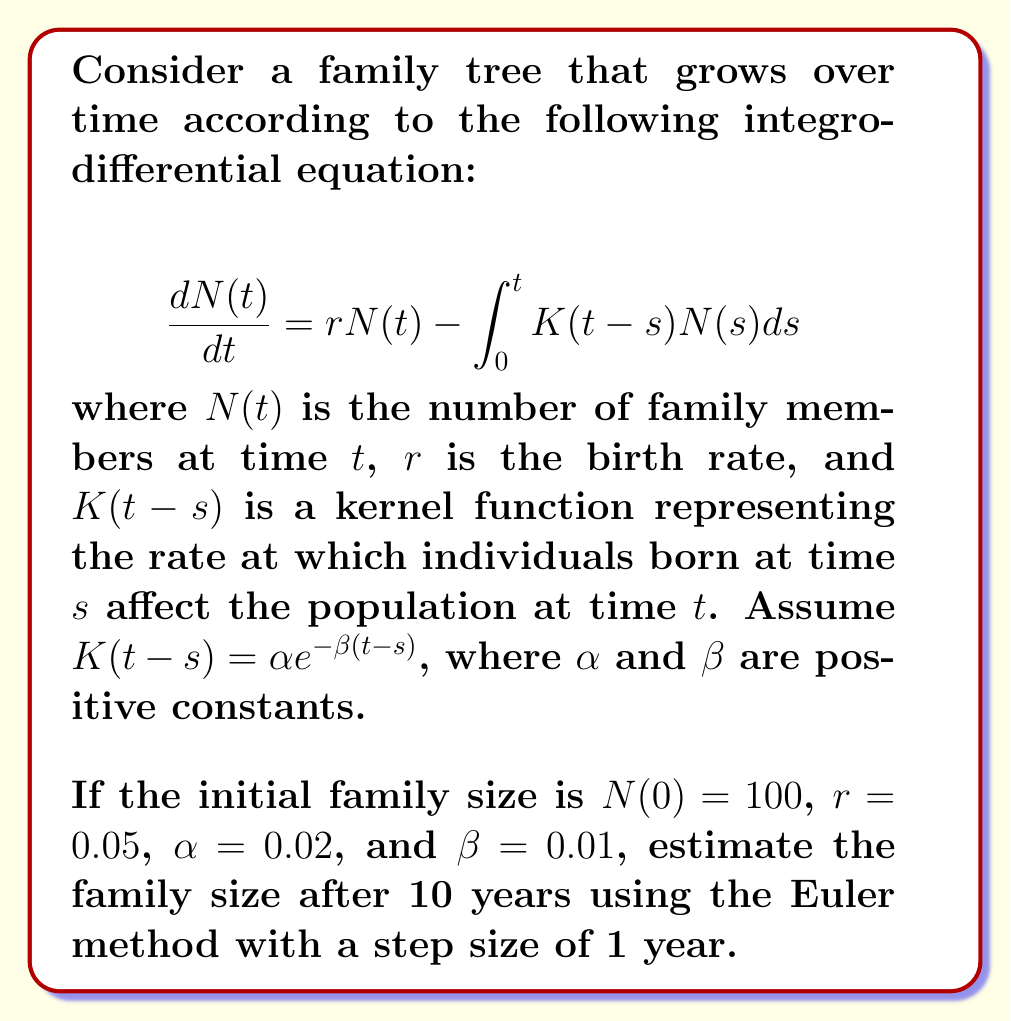Can you answer this question? To solve this problem, we'll use the Euler method to approximate the solution of the integro-differential equation. Here's a step-by-step approach:

1) The Euler method for our equation is:

   $$N(t_{i+1}) = N(t_i) + \Delta t \left(rN(t_i) - \int_{0}^{t_i} K(t_i-s)N(s)ds\right)$$

   where $\Delta t = 1$ year (given step size).

2) We need to approximate the integral at each step. We'll use the trapezoidal rule:

   $$\int_{0}^{t_i} K(t_i-s)N(s)ds \approx \frac{\Delta t}{2} \sum_{j=0}^{i} (K(t_i-t_j)N(t_j) + K(t_i-t_{j+1})N(t_{j+1}))$$

3) Now, let's calculate step by step:

   For $t = 0$: $N(0) = 100$

   For $t = 1$:
   $$N(1) = 100 + 1 \cdot (0.05 \cdot 100 - 0) = 105$$

   For $t = 2$:
   $$N(2) = 105 + 1 \cdot (0.05 \cdot 105 - 0.5 \cdot (0.02e^{-0.01 \cdot 0} \cdot 100 + 0.02e^{-0.01 \cdot 1} \cdot 105)) = 110.0050$$

   We continue this process for $t = 3, 4, ..., 10$.

4) After calculating for all 10 steps, we get:

   $N(10) \approx 147.7048$

Therefore, the estimated family size after 10 years is approximately 148 members.
Answer: 148 members 